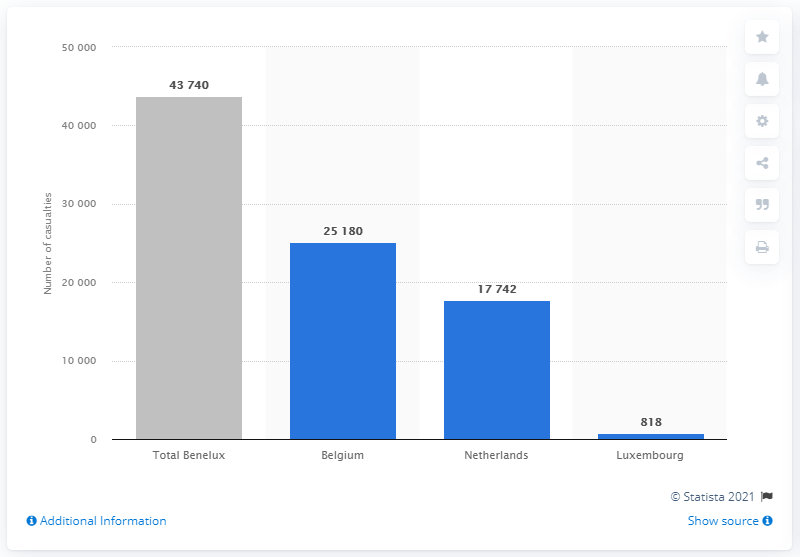Identify some key points in this picture. The death toll in the Netherlands was 17,742. As of June 30, 2021, in the Benelux countries a total of 43,740 deaths were due to COVID-19. The death toll in Belgium was 25,180. 